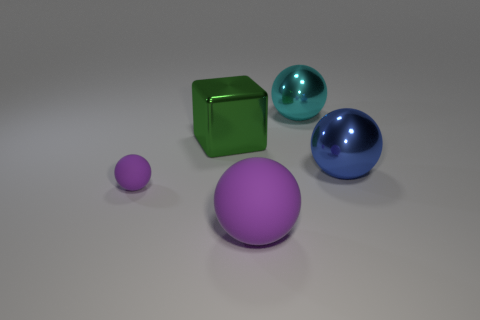Add 4 purple blocks. How many objects exist? 9 Subtract all yellow spheres. Subtract all gray cylinders. How many spheres are left? 4 Subtract all balls. How many objects are left? 1 Subtract all metal blocks. Subtract all purple balls. How many objects are left? 2 Add 3 small rubber things. How many small rubber things are left? 4 Add 1 large cyan rubber objects. How many large cyan rubber objects exist? 1 Subtract 0 cyan cylinders. How many objects are left? 5 